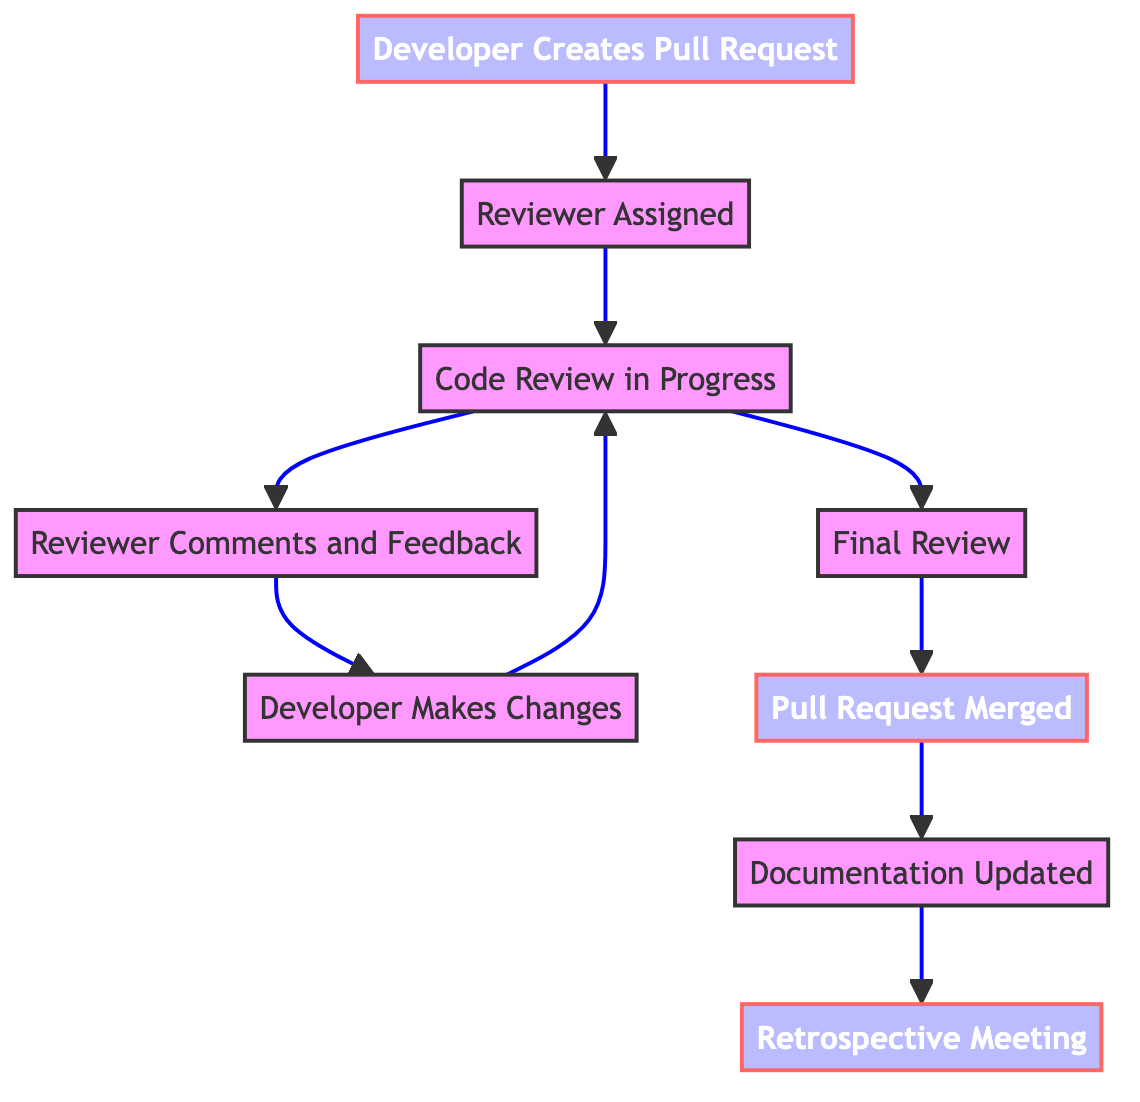What is the first node in the workflow? The first node in the workflow is identified by its positioning in the diagram. It is labeled "Developer Creates Pull Request" and can be easily spotted as the starting point of the directed graph.
Answer: Developer Creates Pull Request How many nodes are present in the diagram? To find the number of nodes, we can simply count each node presented in the data. There are nine distinct labeled nodes in the diagram.
Answer: 9 What happens immediately after the "Reviewer Comments and Feedback"? The flow indicates what follows after "Reviewer Comments and Feedback". According to the directed edges coming from that node, the next step is "Developer Makes Changes".
Answer: Developer Makes Changes Which node represents the final step in the workflow? The final step is identified by looking for the last node in the flowchart. The last node is labeled "Retrospective Meeting", which concludes the process.
Answer: Retrospective Meeting How many edges connect the "Pull Request Merged" node? To find the number of edges connecting "Pull Request Merged", we look for all directed connections coming from that node. There is only one edge connecting it to "Documentation Updated".
Answer: 1 What is the relationship between "Code Review in Progress" and "Final Review"? The relationship between these two nodes can be analyzed through the directed edge in the diagram. "Code Review in Progress" points directly to "Final Review", indicating that once the review is in progress, it proceeds to final review.
Answer: Code Review in Progress points to Final Review Which node does the "Developer Makes Changes" lead back to? To answer this, we need to trace the directed edge from "Developer Makes Changes". The arrow indicates it leads back to "Code Review in Progress", showing that after changes, the review cycle continues.
Answer: Code Review in Progress How many total edges are present in the diagram? We can find the total number of edges by counting each directed connection in the data. There are eight edges connecting the nodes throughout the workflow.
Answer: 8 